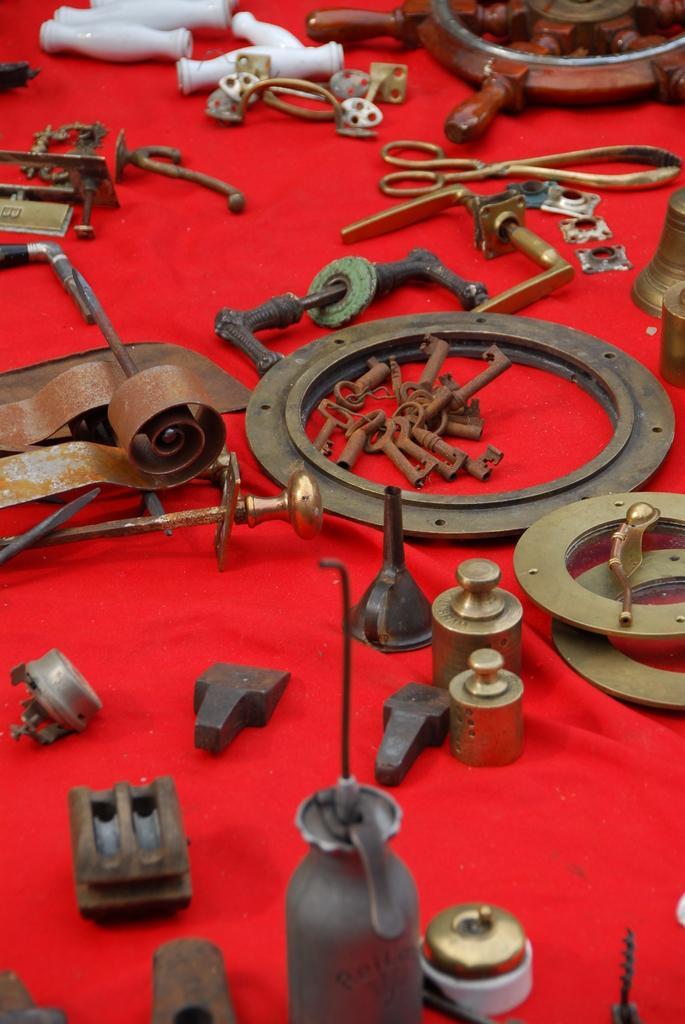In one or two sentences, can you explain what this image depicts? In this image there is a table on which there is a red carpet. On the red carpet there are so many machinery tools like screws and some iron parts on it. 